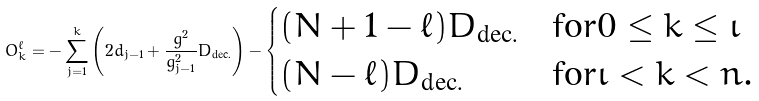Convert formula to latex. <formula><loc_0><loc_0><loc_500><loc_500>O ^ { \ell } _ { k } = - \sum _ { j = 1 } ^ { k } \left ( 2 d _ { j - 1 } + \frac { g ^ { 2 } } { g _ { j - 1 } ^ { 2 } } D _ { \text {dec.} } \right ) - \begin{cases} ( N + 1 - \ell ) D _ { \text {dec.} } & \text {for} 0 \leq k \leq \iota \\ ( N - \ell ) D _ { \text {dec.} } & \text {for} \iota < k < n . \end{cases}</formula> 